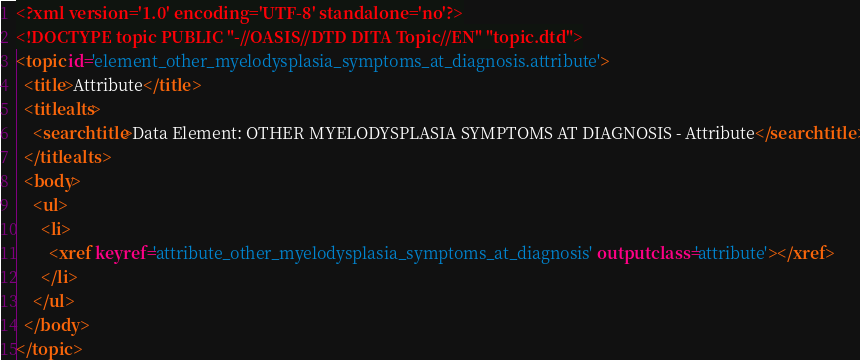Convert code to text. <code><loc_0><loc_0><loc_500><loc_500><_XML_><?xml version='1.0' encoding='UTF-8' standalone='no'?>
<!DOCTYPE topic PUBLIC "-//OASIS//DTD DITA Topic//EN" "topic.dtd">
<topic id='element_other_myelodysplasia_symptoms_at_diagnosis.attribute'>
  <title>Attribute</title>
  <titlealts>
    <searchtitle>Data Element: OTHER MYELODYSPLASIA SYMPTOMS AT DIAGNOSIS - Attribute</searchtitle>
  </titlealts>
  <body>
    <ul>
      <li>
        <xref keyref='attribute_other_myelodysplasia_symptoms_at_diagnosis' outputclass='attribute'></xref>
      </li>
    </ul>
  </body>
</topic></code> 